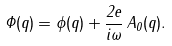Convert formula to latex. <formula><loc_0><loc_0><loc_500><loc_500>\Phi ( q ) = \phi ( q ) + \frac { 2 e } { i \omega } \, A _ { 0 } ( q ) .</formula> 